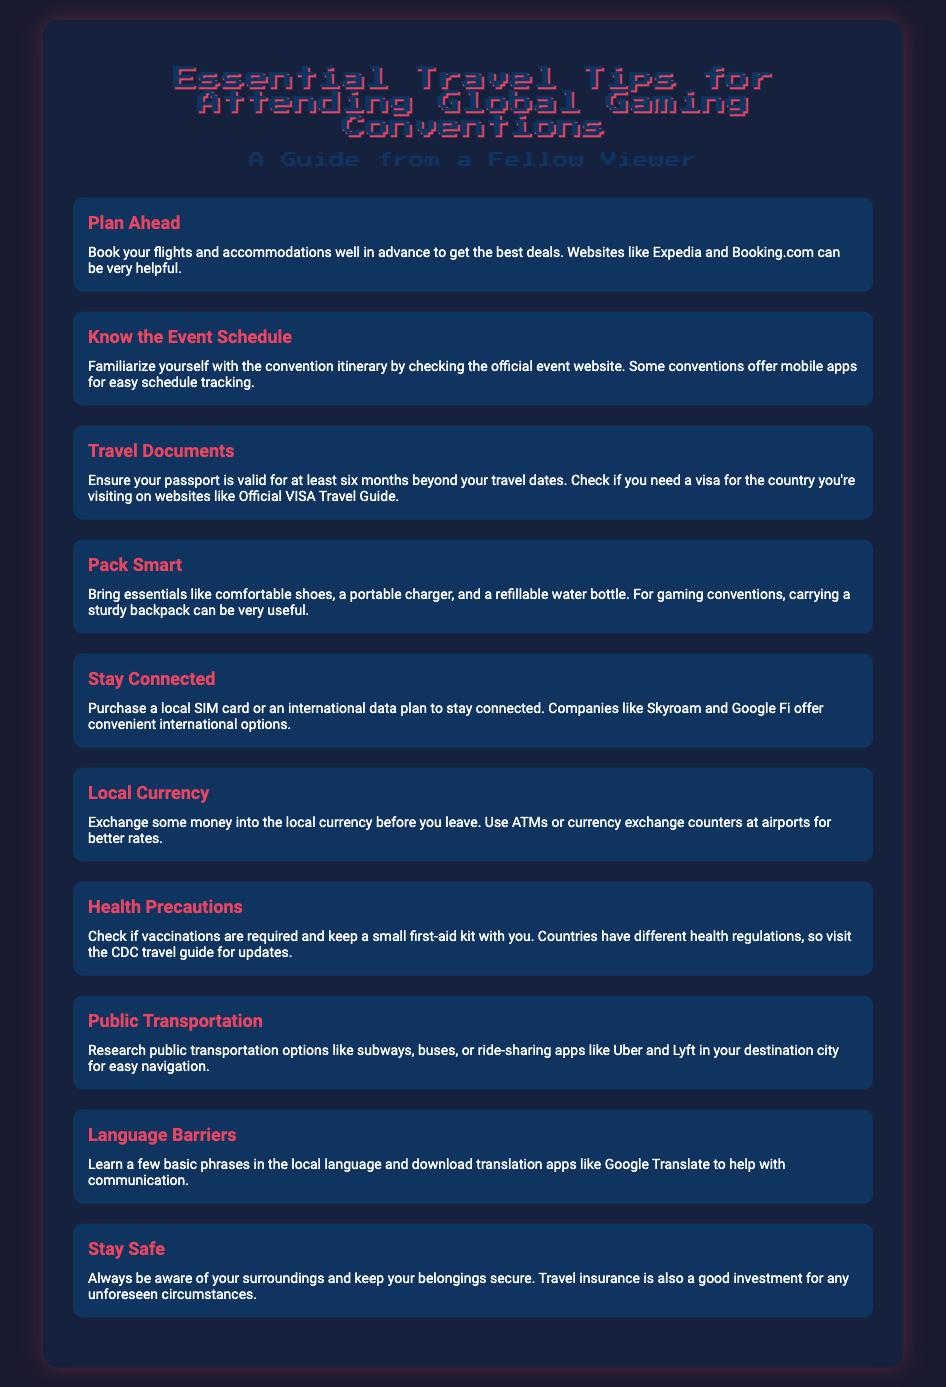what is the title of the document? The title of the document is given in the main heading at the top.
Answer: Essential Travel Tips for Attending Global Gaming Conventions how many tips are listed in the document? The number of tips can be counted from the list items provided.
Answer: 10 what is a recommended action for traveling documents? The document specifies an important requirement regarding passports in the travel documents section.
Answer: Ensure passport is valid for at least six months what should you exchange before leaving? This information is related to the financial advice given in the document.
Answer: Local currency which mobile app is suggested for translation? This question refers to resources mentioned for overcoming communication barriers in the document.
Answer: Google Translate what is one packing essential mentioned? The packing essentials are enumerated as part of the packing tips in the document.
Answer: Comfortable shoes what is the advice for staying connected? The document provides recommendations for maintaining connectivity while traveling.
Answer: Purchase a local SIM card where can you find the convention itinerary? The document suggests a source for checking event schedules.
Answer: Official event website what type of insurance is suggested? This question pertains to the safety measures outlined in the document.
Answer: Travel insurance which companies offer international data plans? Companies that provide international data options are mentioned in the tips.
Answer: Skyroam and Google Fi 